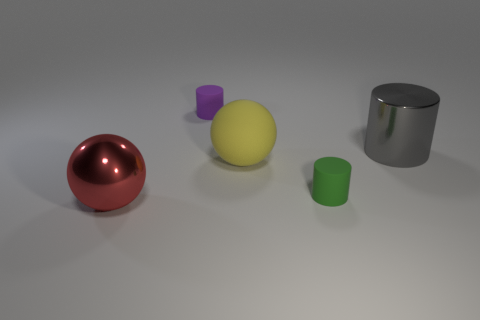Add 4 green metal things. How many objects exist? 9 Subtract all small cylinders. How many cylinders are left? 1 Subtract all gray cylinders. How many cylinders are left? 2 Subtract all cyan spheres. Subtract all brown cubes. How many spheres are left? 2 Subtract all cyan blocks. How many gray cylinders are left? 1 Subtract all red metallic balls. Subtract all red shiny objects. How many objects are left? 3 Add 4 big matte spheres. How many big matte spheres are left? 5 Add 2 green cylinders. How many green cylinders exist? 3 Subtract 0 blue spheres. How many objects are left? 5 Subtract all balls. How many objects are left? 3 